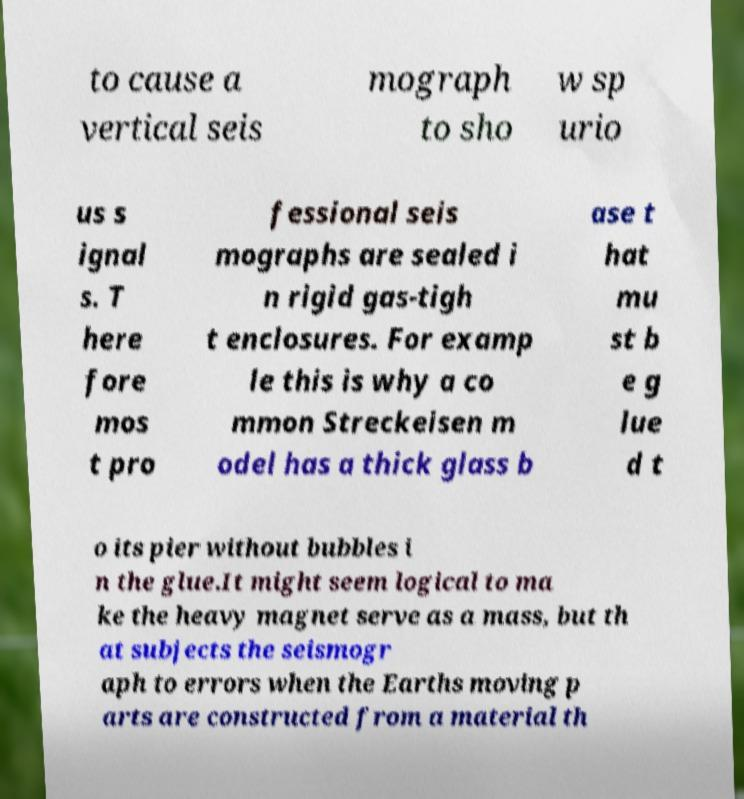There's text embedded in this image that I need extracted. Can you transcribe it verbatim? to cause a vertical seis mograph to sho w sp urio us s ignal s. T here fore mos t pro fessional seis mographs are sealed i n rigid gas-tigh t enclosures. For examp le this is why a co mmon Streckeisen m odel has a thick glass b ase t hat mu st b e g lue d t o its pier without bubbles i n the glue.It might seem logical to ma ke the heavy magnet serve as a mass, but th at subjects the seismogr aph to errors when the Earths moving p arts are constructed from a material th 